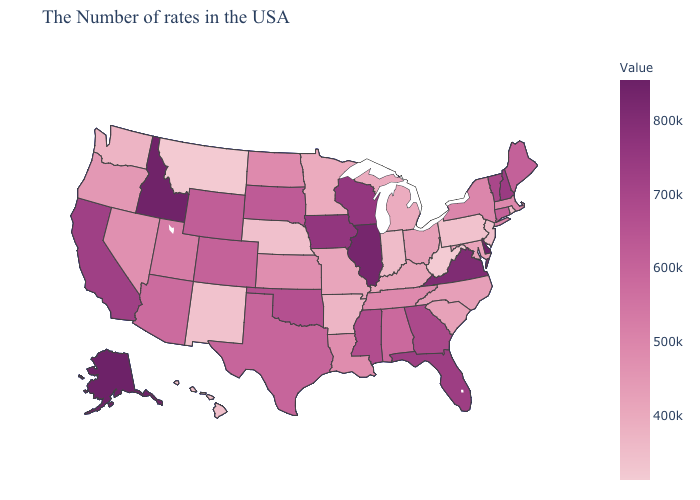Does Delaware have the highest value in the USA?
Write a very short answer. Yes. Among the states that border Missouri , which have the highest value?
Give a very brief answer. Illinois. Does Hawaii have the lowest value in the USA?
Write a very short answer. No. Which states have the lowest value in the South?
Short answer required. West Virginia. Does Delaware have the highest value in the USA?
Give a very brief answer. Yes. 